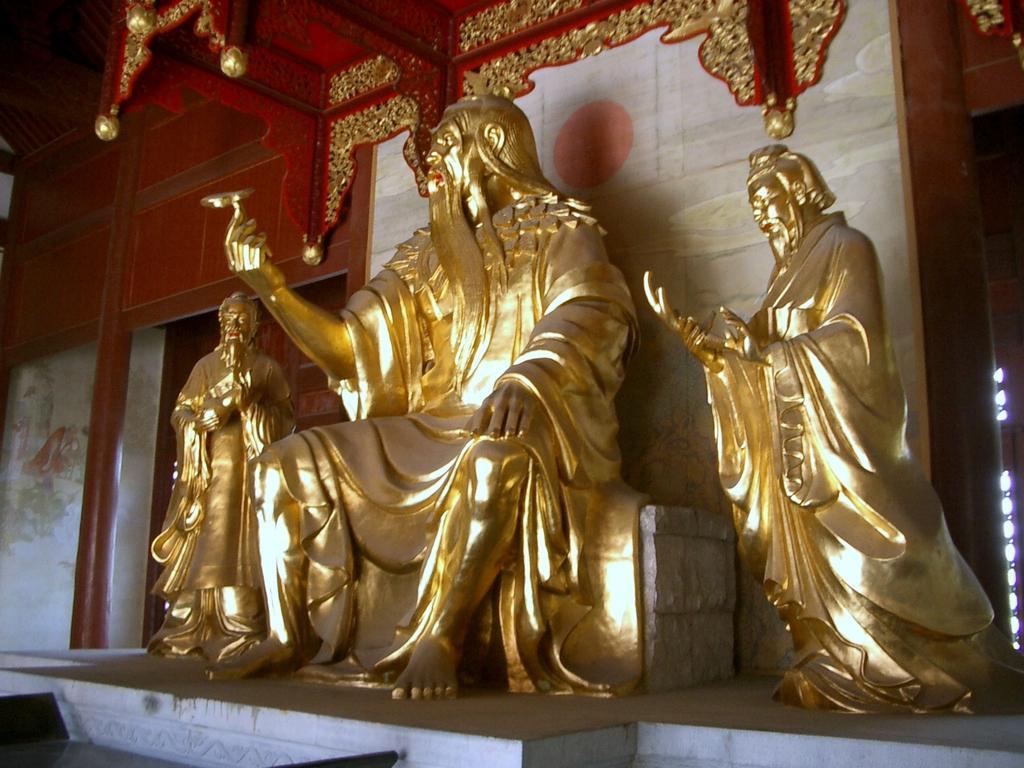Can you describe this image briefly? In this image I can see three idols of a person's on the wall. In the background, I can see a red color pole. 